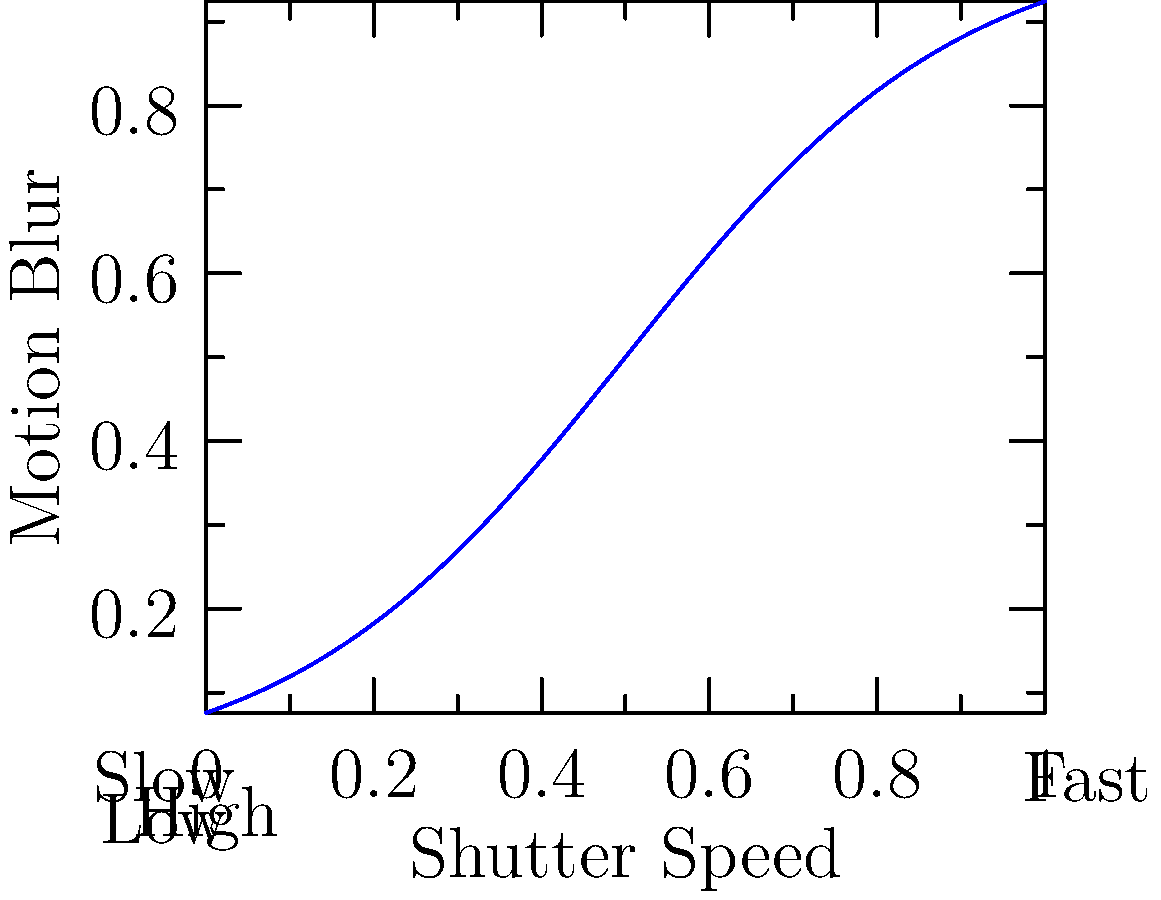In nighttime city photography, how does the relationship between shutter speed and motion blur affect the capture of light trails from moving vehicles? To understand the relationship between shutter speed and motion blur in nighttime city photography, particularly for capturing light trails, we need to consider the following steps:

1. Shutter speed basics:
   - Slow shutter speeds allow more light to enter the camera.
   - Fast shutter speeds allow less light to enter the camera.

2. Motion blur creation:
   - Motion blur occurs when the subject moves during the exposure.
   - The amount of blur is directly related to the shutter speed and subject movement.

3. Light trail formation:
   - Light trails are created by the movement of light sources (e.g., car headlights) during a long exposure.
   - Longer exposures (slower shutter speeds) result in longer, more pronounced light trails.

4. Relationship analysis:
   - As shown in the graph, there's an inverse relationship between shutter speed and motion blur.
   - Slower shutter speeds (left side of x-axis) result in more motion blur (higher on y-axis).
   - Faster shutter speeds (right side of x-axis) result in less motion blur (lower on y-axis).

5. Optimal settings for light trails:
   - To capture long, dramatic light trails, use slower shutter speeds (e.g., 1 second to 30 seconds).
   - This allows moving vehicles' lights to create streaks across the frame.

6. Additional considerations:
   - Use a tripod to keep the camera stable during long exposures.
   - Adjust the aperture and ISO to balance the overall exposure.
Answer: Inverse relationship: slower shutter speeds produce more motion blur, creating longer light trails. 